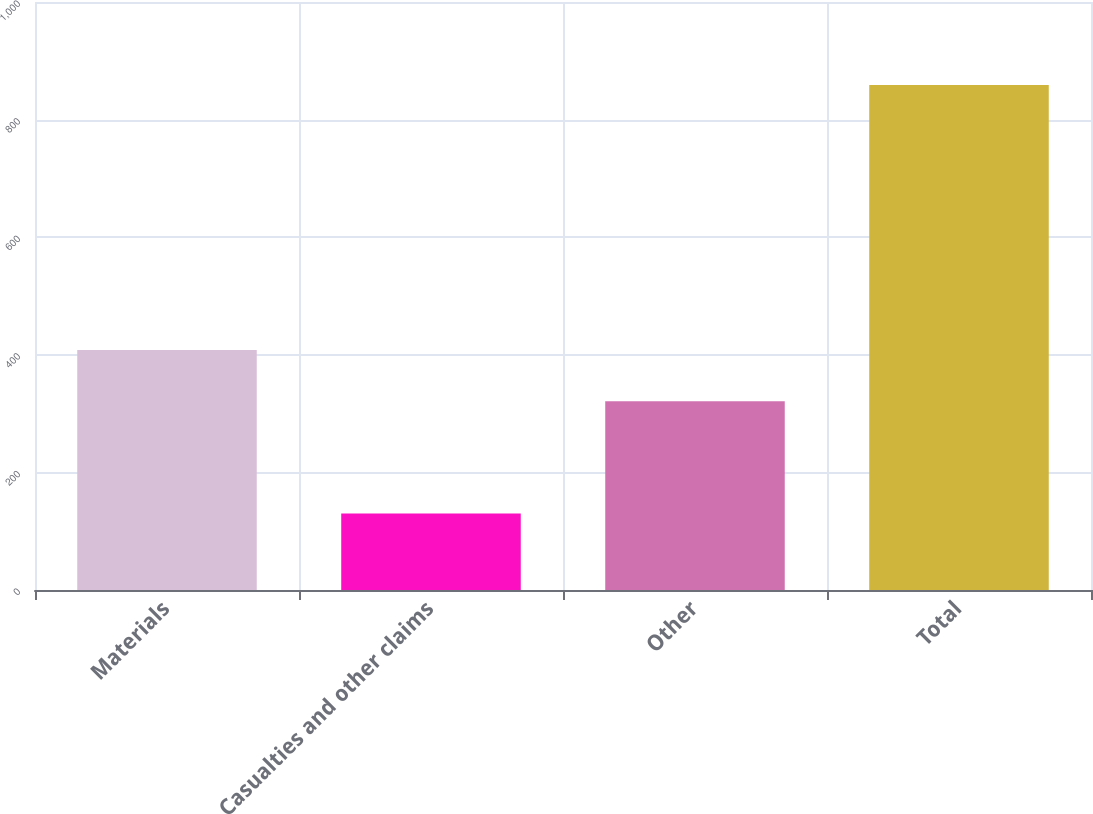<chart> <loc_0><loc_0><loc_500><loc_500><bar_chart><fcel>Materials<fcel>Casualties and other claims<fcel>Other<fcel>Total<nl><fcel>408<fcel>130<fcel>321<fcel>859<nl></chart> 